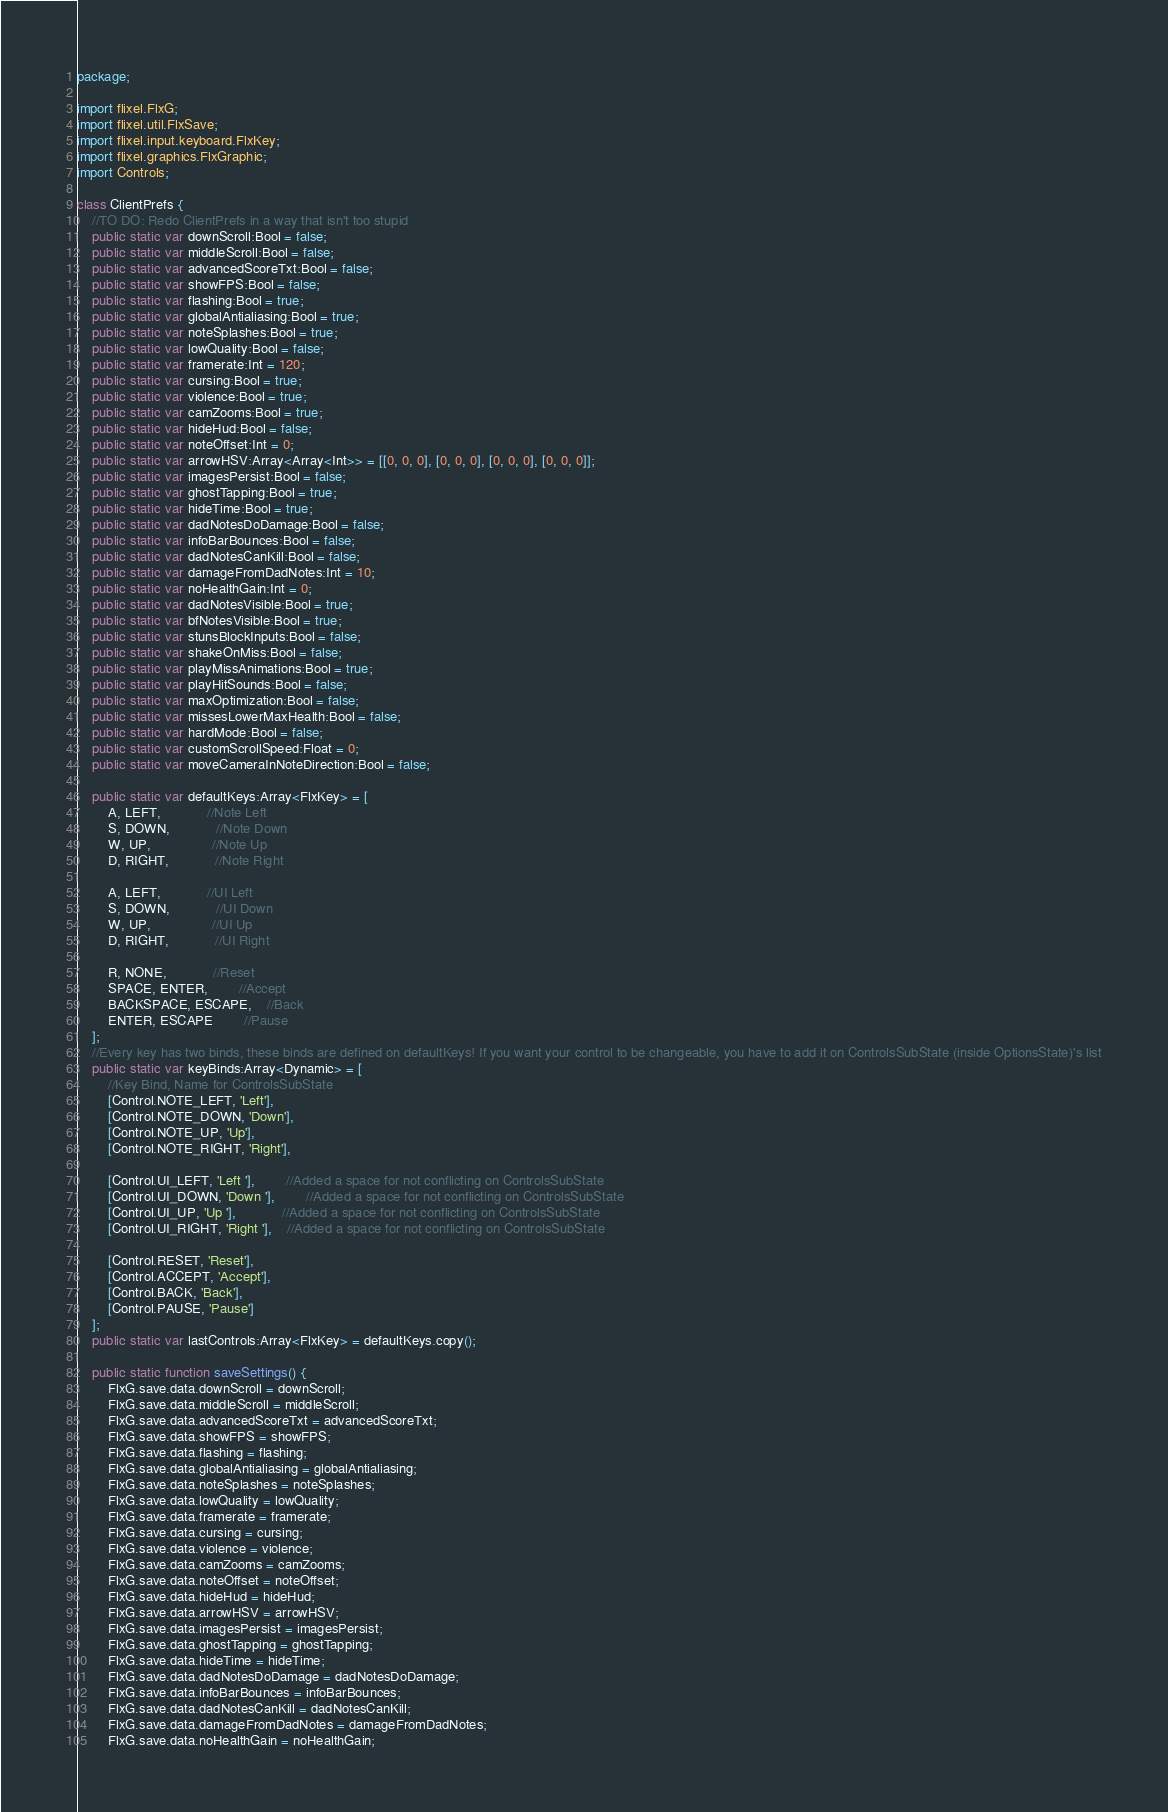Convert code to text. <code><loc_0><loc_0><loc_500><loc_500><_Haxe_>package;

import flixel.FlxG;
import flixel.util.FlxSave;
import flixel.input.keyboard.FlxKey;
import flixel.graphics.FlxGraphic;
import Controls;

class ClientPrefs {
	//TO DO: Redo ClientPrefs in a way that isn't too stupid
	public static var downScroll:Bool = false;
	public static var middleScroll:Bool = false;
	public static var advancedScoreTxt:Bool = false;
	public static var showFPS:Bool = false;
	public static var flashing:Bool = true;
	public static var globalAntialiasing:Bool = true;
	public static var noteSplashes:Bool = true;
	public static var lowQuality:Bool = false;
	public static var framerate:Int = 120;
	public static var cursing:Bool = true;
	public static var violence:Bool = true;
	public static var camZooms:Bool = true;
	public static var hideHud:Bool = false;
	public static var noteOffset:Int = 0;
	public static var arrowHSV:Array<Array<Int>> = [[0, 0, 0], [0, 0, 0], [0, 0, 0], [0, 0, 0]];
	public static var imagesPersist:Bool = false;
	public static var ghostTapping:Bool = true;
	public static var hideTime:Bool = true;
	public static var dadNotesDoDamage:Bool = false;
	public static var infoBarBounces:Bool = false;
	public static var dadNotesCanKill:Bool = false;
	public static var damageFromDadNotes:Int = 10;
	public static var noHealthGain:Int = 0;
	public static var dadNotesVisible:Bool = true;
	public static var bfNotesVisible:Bool = true;
	public static var stunsBlockInputs:Bool = false;
	public static var shakeOnMiss:Bool = false;
	public static var playMissAnimations:Bool = true;
	public static var playHitSounds:Bool = false;
	public static var maxOptimization:Bool = false;
	public static var missesLowerMaxHealth:Bool = false;
	public static var hardMode:Bool = false;
	public static var customScrollSpeed:Float = 0;
	public static var moveCameraInNoteDirection:Bool = false;

	public static var defaultKeys:Array<FlxKey> = [
		A, LEFT,			//Note Left
		S, DOWN,			//Note Down
		W, UP,				//Note Up
		D, RIGHT,			//Note Right

		A, LEFT,			//UI Left
		S, DOWN,			//UI Down
		W, UP,				//UI Up
		D, RIGHT,			//UI Right

		R, NONE,			//Reset
		SPACE, ENTER,		//Accept
		BACKSPACE, ESCAPE,	//Back
		ENTER, ESCAPE		//Pause
	];
	//Every key has two binds, these binds are defined on defaultKeys! If you want your control to be changeable, you have to add it on ControlsSubState (inside OptionsState)'s list
	public static var keyBinds:Array<Dynamic> = [
		//Key Bind, Name for ControlsSubState
		[Control.NOTE_LEFT, 'Left'],
		[Control.NOTE_DOWN, 'Down'],
		[Control.NOTE_UP, 'Up'],
		[Control.NOTE_RIGHT, 'Right'],

		[Control.UI_LEFT, 'Left '],		//Added a space for not conflicting on ControlsSubState
		[Control.UI_DOWN, 'Down '],		//Added a space for not conflicting on ControlsSubState
		[Control.UI_UP, 'Up '],			//Added a space for not conflicting on ControlsSubState
		[Control.UI_RIGHT, 'Right '],	//Added a space for not conflicting on ControlsSubState

		[Control.RESET, 'Reset'],
		[Control.ACCEPT, 'Accept'],
		[Control.BACK, 'Back'],
		[Control.PAUSE, 'Pause']
	];
	public static var lastControls:Array<FlxKey> = defaultKeys.copy();

	public static function saveSettings() {
		FlxG.save.data.downScroll = downScroll;
		FlxG.save.data.middleScroll = middleScroll;
		FlxG.save.data.advancedScoreTxt = advancedScoreTxt;
		FlxG.save.data.showFPS = showFPS;
		FlxG.save.data.flashing = flashing;
		FlxG.save.data.globalAntialiasing = globalAntialiasing;
		FlxG.save.data.noteSplashes = noteSplashes;
		FlxG.save.data.lowQuality = lowQuality;
		FlxG.save.data.framerate = framerate;
		FlxG.save.data.cursing = cursing;
		FlxG.save.data.violence = violence;
		FlxG.save.data.camZooms = camZooms;
		FlxG.save.data.noteOffset = noteOffset;
		FlxG.save.data.hideHud = hideHud;
		FlxG.save.data.arrowHSV = arrowHSV;
		FlxG.save.data.imagesPersist = imagesPersist;
		FlxG.save.data.ghostTapping = ghostTapping;
		FlxG.save.data.hideTime = hideTime;
		FlxG.save.data.dadNotesDoDamage = dadNotesDoDamage;
		FlxG.save.data.infoBarBounces = infoBarBounces;
		FlxG.save.data.dadNotesCanKill = dadNotesCanKill;
		FlxG.save.data.damageFromDadNotes = damageFromDadNotes;
		FlxG.save.data.noHealthGain = noHealthGain;</code> 